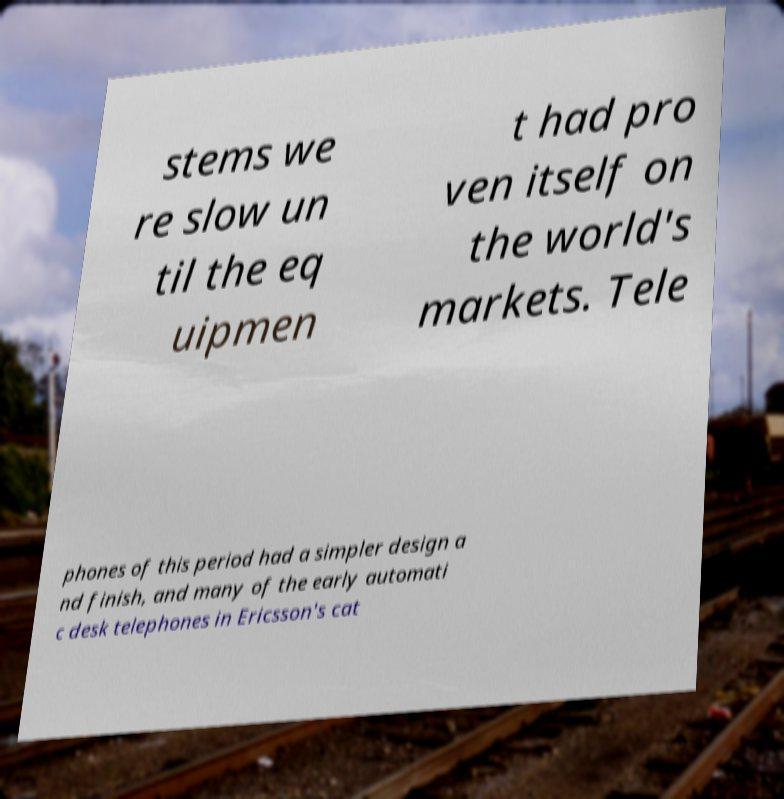Please read and relay the text visible in this image. What does it say? stems we re slow un til the eq uipmen t had pro ven itself on the world's markets. Tele phones of this period had a simpler design a nd finish, and many of the early automati c desk telephones in Ericsson's cat 